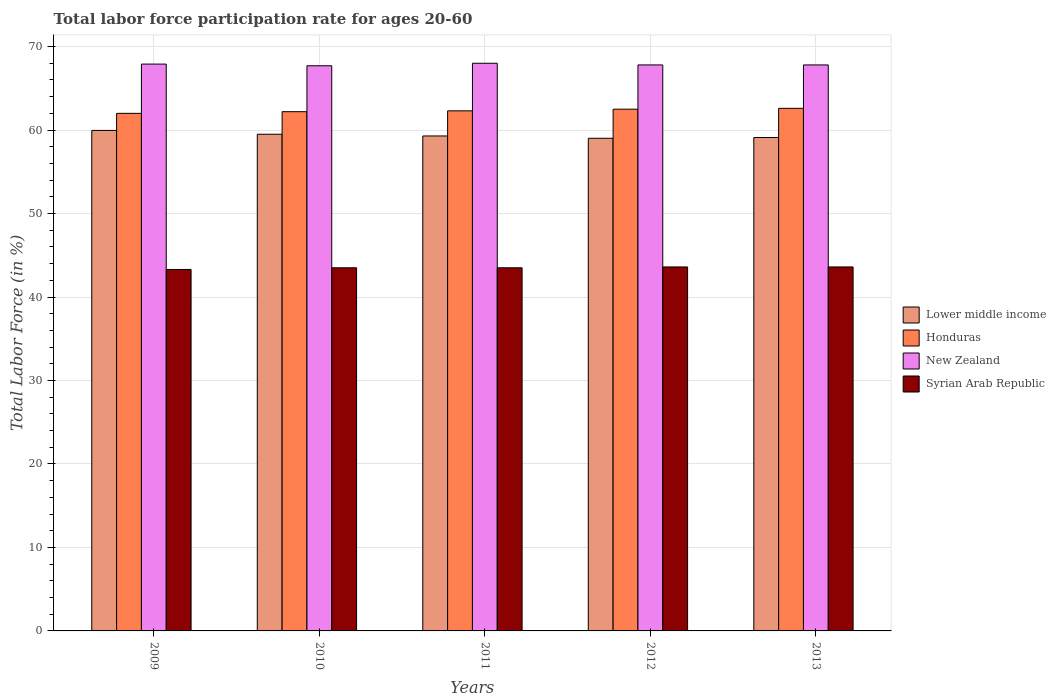How many different coloured bars are there?
Your response must be concise. 4. How many groups of bars are there?
Offer a very short reply. 5. Are the number of bars per tick equal to the number of legend labels?
Your response must be concise. Yes. Are the number of bars on each tick of the X-axis equal?
Ensure brevity in your answer.  Yes. How many bars are there on the 1st tick from the right?
Provide a short and direct response. 4. What is the label of the 5th group of bars from the left?
Ensure brevity in your answer.  2013. In how many cases, is the number of bars for a given year not equal to the number of legend labels?
Provide a short and direct response. 0. What is the labor force participation rate in New Zealand in 2009?
Offer a very short reply. 67.9. Across all years, what is the maximum labor force participation rate in Syrian Arab Republic?
Your response must be concise. 43.6. Across all years, what is the minimum labor force participation rate in Syrian Arab Republic?
Offer a terse response. 43.3. In which year was the labor force participation rate in Lower middle income minimum?
Your answer should be compact. 2012. What is the total labor force participation rate in Syrian Arab Republic in the graph?
Provide a short and direct response. 217.5. What is the difference between the labor force participation rate in New Zealand in 2010 and that in 2013?
Your answer should be very brief. -0.1. What is the difference between the labor force participation rate in New Zealand in 2009 and the labor force participation rate in Syrian Arab Republic in 2012?
Your answer should be very brief. 24.3. What is the average labor force participation rate in Lower middle income per year?
Provide a succinct answer. 59.37. In the year 2012, what is the difference between the labor force participation rate in Lower middle income and labor force participation rate in Syrian Arab Republic?
Offer a very short reply. 15.41. In how many years, is the labor force participation rate in New Zealand greater than 68 %?
Ensure brevity in your answer.  0. What is the ratio of the labor force participation rate in New Zealand in 2010 to that in 2011?
Make the answer very short. 1. Is the difference between the labor force participation rate in Lower middle income in 2009 and 2010 greater than the difference between the labor force participation rate in Syrian Arab Republic in 2009 and 2010?
Ensure brevity in your answer.  Yes. What is the difference between the highest and the second highest labor force participation rate in Honduras?
Offer a very short reply. 0.1. What is the difference between the highest and the lowest labor force participation rate in New Zealand?
Your answer should be very brief. 0.3. Is the sum of the labor force participation rate in Lower middle income in 2011 and 2013 greater than the maximum labor force participation rate in New Zealand across all years?
Make the answer very short. Yes. Is it the case that in every year, the sum of the labor force participation rate in New Zealand and labor force participation rate in Honduras is greater than the sum of labor force participation rate in Lower middle income and labor force participation rate in Syrian Arab Republic?
Offer a very short reply. Yes. What does the 4th bar from the left in 2009 represents?
Make the answer very short. Syrian Arab Republic. What does the 1st bar from the right in 2013 represents?
Provide a short and direct response. Syrian Arab Republic. How many years are there in the graph?
Your answer should be very brief. 5. What is the difference between two consecutive major ticks on the Y-axis?
Your response must be concise. 10. Are the values on the major ticks of Y-axis written in scientific E-notation?
Ensure brevity in your answer.  No. Does the graph contain grids?
Give a very brief answer. Yes. Where does the legend appear in the graph?
Offer a terse response. Center right. How many legend labels are there?
Give a very brief answer. 4. How are the legend labels stacked?
Offer a terse response. Vertical. What is the title of the graph?
Make the answer very short. Total labor force participation rate for ages 20-60. Does "Low income" appear as one of the legend labels in the graph?
Ensure brevity in your answer.  No. What is the label or title of the Y-axis?
Make the answer very short. Total Labor Force (in %). What is the Total Labor Force (in %) in Lower middle income in 2009?
Your answer should be very brief. 59.95. What is the Total Labor Force (in %) of Honduras in 2009?
Keep it short and to the point. 62. What is the Total Labor Force (in %) in New Zealand in 2009?
Keep it short and to the point. 67.9. What is the Total Labor Force (in %) of Syrian Arab Republic in 2009?
Offer a very short reply. 43.3. What is the Total Labor Force (in %) in Lower middle income in 2010?
Ensure brevity in your answer.  59.5. What is the Total Labor Force (in %) of Honduras in 2010?
Your response must be concise. 62.2. What is the Total Labor Force (in %) in New Zealand in 2010?
Offer a very short reply. 67.7. What is the Total Labor Force (in %) in Syrian Arab Republic in 2010?
Offer a terse response. 43.5. What is the Total Labor Force (in %) of Lower middle income in 2011?
Ensure brevity in your answer.  59.29. What is the Total Labor Force (in %) of Honduras in 2011?
Offer a very short reply. 62.3. What is the Total Labor Force (in %) in Syrian Arab Republic in 2011?
Your response must be concise. 43.5. What is the Total Labor Force (in %) in Lower middle income in 2012?
Offer a terse response. 59.01. What is the Total Labor Force (in %) of Honduras in 2012?
Your response must be concise. 62.5. What is the Total Labor Force (in %) in New Zealand in 2012?
Your answer should be very brief. 67.8. What is the Total Labor Force (in %) in Syrian Arab Republic in 2012?
Offer a very short reply. 43.6. What is the Total Labor Force (in %) of Lower middle income in 2013?
Your answer should be very brief. 59.11. What is the Total Labor Force (in %) of Honduras in 2013?
Provide a succinct answer. 62.6. What is the Total Labor Force (in %) of New Zealand in 2013?
Your answer should be very brief. 67.8. What is the Total Labor Force (in %) in Syrian Arab Republic in 2013?
Offer a terse response. 43.6. Across all years, what is the maximum Total Labor Force (in %) in Lower middle income?
Your answer should be very brief. 59.95. Across all years, what is the maximum Total Labor Force (in %) in Honduras?
Your answer should be compact. 62.6. Across all years, what is the maximum Total Labor Force (in %) in New Zealand?
Offer a very short reply. 68. Across all years, what is the maximum Total Labor Force (in %) of Syrian Arab Republic?
Your answer should be compact. 43.6. Across all years, what is the minimum Total Labor Force (in %) of Lower middle income?
Make the answer very short. 59.01. Across all years, what is the minimum Total Labor Force (in %) of New Zealand?
Make the answer very short. 67.7. Across all years, what is the minimum Total Labor Force (in %) of Syrian Arab Republic?
Make the answer very short. 43.3. What is the total Total Labor Force (in %) of Lower middle income in the graph?
Keep it short and to the point. 296.86. What is the total Total Labor Force (in %) in Honduras in the graph?
Give a very brief answer. 311.6. What is the total Total Labor Force (in %) in New Zealand in the graph?
Offer a very short reply. 339.2. What is the total Total Labor Force (in %) in Syrian Arab Republic in the graph?
Make the answer very short. 217.5. What is the difference between the Total Labor Force (in %) of Lower middle income in 2009 and that in 2010?
Your answer should be compact. 0.46. What is the difference between the Total Labor Force (in %) in Honduras in 2009 and that in 2010?
Provide a succinct answer. -0.2. What is the difference between the Total Labor Force (in %) of Syrian Arab Republic in 2009 and that in 2010?
Your answer should be very brief. -0.2. What is the difference between the Total Labor Force (in %) of Lower middle income in 2009 and that in 2011?
Your response must be concise. 0.66. What is the difference between the Total Labor Force (in %) of Lower middle income in 2009 and that in 2012?
Your response must be concise. 0.94. What is the difference between the Total Labor Force (in %) of Honduras in 2009 and that in 2012?
Your response must be concise. -0.5. What is the difference between the Total Labor Force (in %) of Syrian Arab Republic in 2009 and that in 2012?
Provide a succinct answer. -0.3. What is the difference between the Total Labor Force (in %) of Lower middle income in 2009 and that in 2013?
Give a very brief answer. 0.85. What is the difference between the Total Labor Force (in %) of Honduras in 2009 and that in 2013?
Ensure brevity in your answer.  -0.6. What is the difference between the Total Labor Force (in %) of New Zealand in 2009 and that in 2013?
Your response must be concise. 0.1. What is the difference between the Total Labor Force (in %) of Syrian Arab Republic in 2009 and that in 2013?
Offer a very short reply. -0.3. What is the difference between the Total Labor Force (in %) in Lower middle income in 2010 and that in 2011?
Make the answer very short. 0.21. What is the difference between the Total Labor Force (in %) in New Zealand in 2010 and that in 2011?
Ensure brevity in your answer.  -0.3. What is the difference between the Total Labor Force (in %) of Syrian Arab Republic in 2010 and that in 2011?
Your response must be concise. 0. What is the difference between the Total Labor Force (in %) in Lower middle income in 2010 and that in 2012?
Your answer should be very brief. 0.48. What is the difference between the Total Labor Force (in %) in Syrian Arab Republic in 2010 and that in 2012?
Keep it short and to the point. -0.1. What is the difference between the Total Labor Force (in %) in Lower middle income in 2010 and that in 2013?
Offer a very short reply. 0.39. What is the difference between the Total Labor Force (in %) of New Zealand in 2010 and that in 2013?
Make the answer very short. -0.1. What is the difference between the Total Labor Force (in %) of Lower middle income in 2011 and that in 2012?
Give a very brief answer. 0.28. What is the difference between the Total Labor Force (in %) of New Zealand in 2011 and that in 2012?
Make the answer very short. 0.2. What is the difference between the Total Labor Force (in %) of Lower middle income in 2011 and that in 2013?
Offer a terse response. 0.19. What is the difference between the Total Labor Force (in %) of Syrian Arab Republic in 2011 and that in 2013?
Offer a terse response. -0.1. What is the difference between the Total Labor Force (in %) in Lower middle income in 2012 and that in 2013?
Your answer should be compact. -0.09. What is the difference between the Total Labor Force (in %) of Honduras in 2012 and that in 2013?
Ensure brevity in your answer.  -0.1. What is the difference between the Total Labor Force (in %) in Syrian Arab Republic in 2012 and that in 2013?
Ensure brevity in your answer.  0. What is the difference between the Total Labor Force (in %) of Lower middle income in 2009 and the Total Labor Force (in %) of Honduras in 2010?
Make the answer very short. -2.25. What is the difference between the Total Labor Force (in %) of Lower middle income in 2009 and the Total Labor Force (in %) of New Zealand in 2010?
Your answer should be very brief. -7.75. What is the difference between the Total Labor Force (in %) in Lower middle income in 2009 and the Total Labor Force (in %) in Syrian Arab Republic in 2010?
Your answer should be compact. 16.45. What is the difference between the Total Labor Force (in %) in Honduras in 2009 and the Total Labor Force (in %) in New Zealand in 2010?
Your response must be concise. -5.7. What is the difference between the Total Labor Force (in %) of Honduras in 2009 and the Total Labor Force (in %) of Syrian Arab Republic in 2010?
Provide a succinct answer. 18.5. What is the difference between the Total Labor Force (in %) of New Zealand in 2009 and the Total Labor Force (in %) of Syrian Arab Republic in 2010?
Make the answer very short. 24.4. What is the difference between the Total Labor Force (in %) in Lower middle income in 2009 and the Total Labor Force (in %) in Honduras in 2011?
Ensure brevity in your answer.  -2.35. What is the difference between the Total Labor Force (in %) of Lower middle income in 2009 and the Total Labor Force (in %) of New Zealand in 2011?
Your answer should be compact. -8.05. What is the difference between the Total Labor Force (in %) in Lower middle income in 2009 and the Total Labor Force (in %) in Syrian Arab Republic in 2011?
Make the answer very short. 16.45. What is the difference between the Total Labor Force (in %) of New Zealand in 2009 and the Total Labor Force (in %) of Syrian Arab Republic in 2011?
Provide a succinct answer. 24.4. What is the difference between the Total Labor Force (in %) of Lower middle income in 2009 and the Total Labor Force (in %) of Honduras in 2012?
Your answer should be very brief. -2.55. What is the difference between the Total Labor Force (in %) in Lower middle income in 2009 and the Total Labor Force (in %) in New Zealand in 2012?
Give a very brief answer. -7.85. What is the difference between the Total Labor Force (in %) in Lower middle income in 2009 and the Total Labor Force (in %) in Syrian Arab Republic in 2012?
Offer a very short reply. 16.35. What is the difference between the Total Labor Force (in %) of Honduras in 2009 and the Total Labor Force (in %) of Syrian Arab Republic in 2012?
Ensure brevity in your answer.  18.4. What is the difference between the Total Labor Force (in %) in New Zealand in 2009 and the Total Labor Force (in %) in Syrian Arab Republic in 2012?
Give a very brief answer. 24.3. What is the difference between the Total Labor Force (in %) in Lower middle income in 2009 and the Total Labor Force (in %) in Honduras in 2013?
Provide a succinct answer. -2.65. What is the difference between the Total Labor Force (in %) of Lower middle income in 2009 and the Total Labor Force (in %) of New Zealand in 2013?
Your response must be concise. -7.85. What is the difference between the Total Labor Force (in %) in Lower middle income in 2009 and the Total Labor Force (in %) in Syrian Arab Republic in 2013?
Give a very brief answer. 16.35. What is the difference between the Total Labor Force (in %) of Honduras in 2009 and the Total Labor Force (in %) of New Zealand in 2013?
Give a very brief answer. -5.8. What is the difference between the Total Labor Force (in %) of Honduras in 2009 and the Total Labor Force (in %) of Syrian Arab Republic in 2013?
Provide a short and direct response. 18.4. What is the difference between the Total Labor Force (in %) in New Zealand in 2009 and the Total Labor Force (in %) in Syrian Arab Republic in 2013?
Your response must be concise. 24.3. What is the difference between the Total Labor Force (in %) in Lower middle income in 2010 and the Total Labor Force (in %) in Honduras in 2011?
Provide a succinct answer. -2.8. What is the difference between the Total Labor Force (in %) of Lower middle income in 2010 and the Total Labor Force (in %) of New Zealand in 2011?
Your response must be concise. -8.5. What is the difference between the Total Labor Force (in %) of Lower middle income in 2010 and the Total Labor Force (in %) of Syrian Arab Republic in 2011?
Offer a terse response. 16. What is the difference between the Total Labor Force (in %) of Honduras in 2010 and the Total Labor Force (in %) of New Zealand in 2011?
Ensure brevity in your answer.  -5.8. What is the difference between the Total Labor Force (in %) in New Zealand in 2010 and the Total Labor Force (in %) in Syrian Arab Republic in 2011?
Make the answer very short. 24.2. What is the difference between the Total Labor Force (in %) in Lower middle income in 2010 and the Total Labor Force (in %) in Honduras in 2012?
Offer a terse response. -3. What is the difference between the Total Labor Force (in %) in Lower middle income in 2010 and the Total Labor Force (in %) in New Zealand in 2012?
Provide a short and direct response. -8.3. What is the difference between the Total Labor Force (in %) of Lower middle income in 2010 and the Total Labor Force (in %) of Syrian Arab Republic in 2012?
Your response must be concise. 15.9. What is the difference between the Total Labor Force (in %) of Honduras in 2010 and the Total Labor Force (in %) of New Zealand in 2012?
Ensure brevity in your answer.  -5.6. What is the difference between the Total Labor Force (in %) in Honduras in 2010 and the Total Labor Force (in %) in Syrian Arab Republic in 2012?
Your answer should be compact. 18.6. What is the difference between the Total Labor Force (in %) in New Zealand in 2010 and the Total Labor Force (in %) in Syrian Arab Republic in 2012?
Keep it short and to the point. 24.1. What is the difference between the Total Labor Force (in %) of Lower middle income in 2010 and the Total Labor Force (in %) of Honduras in 2013?
Offer a very short reply. -3.1. What is the difference between the Total Labor Force (in %) in Lower middle income in 2010 and the Total Labor Force (in %) in New Zealand in 2013?
Make the answer very short. -8.3. What is the difference between the Total Labor Force (in %) of Lower middle income in 2010 and the Total Labor Force (in %) of Syrian Arab Republic in 2013?
Your answer should be very brief. 15.9. What is the difference between the Total Labor Force (in %) in Honduras in 2010 and the Total Labor Force (in %) in Syrian Arab Republic in 2013?
Provide a succinct answer. 18.6. What is the difference between the Total Labor Force (in %) in New Zealand in 2010 and the Total Labor Force (in %) in Syrian Arab Republic in 2013?
Provide a short and direct response. 24.1. What is the difference between the Total Labor Force (in %) in Lower middle income in 2011 and the Total Labor Force (in %) in Honduras in 2012?
Offer a very short reply. -3.21. What is the difference between the Total Labor Force (in %) of Lower middle income in 2011 and the Total Labor Force (in %) of New Zealand in 2012?
Ensure brevity in your answer.  -8.51. What is the difference between the Total Labor Force (in %) of Lower middle income in 2011 and the Total Labor Force (in %) of Syrian Arab Republic in 2012?
Provide a succinct answer. 15.69. What is the difference between the Total Labor Force (in %) in New Zealand in 2011 and the Total Labor Force (in %) in Syrian Arab Republic in 2012?
Give a very brief answer. 24.4. What is the difference between the Total Labor Force (in %) in Lower middle income in 2011 and the Total Labor Force (in %) in Honduras in 2013?
Give a very brief answer. -3.31. What is the difference between the Total Labor Force (in %) in Lower middle income in 2011 and the Total Labor Force (in %) in New Zealand in 2013?
Your answer should be compact. -8.51. What is the difference between the Total Labor Force (in %) in Lower middle income in 2011 and the Total Labor Force (in %) in Syrian Arab Republic in 2013?
Keep it short and to the point. 15.69. What is the difference between the Total Labor Force (in %) of New Zealand in 2011 and the Total Labor Force (in %) of Syrian Arab Republic in 2013?
Keep it short and to the point. 24.4. What is the difference between the Total Labor Force (in %) of Lower middle income in 2012 and the Total Labor Force (in %) of Honduras in 2013?
Offer a terse response. -3.59. What is the difference between the Total Labor Force (in %) of Lower middle income in 2012 and the Total Labor Force (in %) of New Zealand in 2013?
Keep it short and to the point. -8.79. What is the difference between the Total Labor Force (in %) of Lower middle income in 2012 and the Total Labor Force (in %) of Syrian Arab Republic in 2013?
Offer a very short reply. 15.41. What is the difference between the Total Labor Force (in %) in New Zealand in 2012 and the Total Labor Force (in %) in Syrian Arab Republic in 2013?
Give a very brief answer. 24.2. What is the average Total Labor Force (in %) in Lower middle income per year?
Provide a succinct answer. 59.37. What is the average Total Labor Force (in %) of Honduras per year?
Keep it short and to the point. 62.32. What is the average Total Labor Force (in %) of New Zealand per year?
Offer a very short reply. 67.84. What is the average Total Labor Force (in %) of Syrian Arab Republic per year?
Your answer should be compact. 43.5. In the year 2009, what is the difference between the Total Labor Force (in %) of Lower middle income and Total Labor Force (in %) of Honduras?
Provide a succinct answer. -2.05. In the year 2009, what is the difference between the Total Labor Force (in %) in Lower middle income and Total Labor Force (in %) in New Zealand?
Offer a terse response. -7.95. In the year 2009, what is the difference between the Total Labor Force (in %) of Lower middle income and Total Labor Force (in %) of Syrian Arab Republic?
Provide a succinct answer. 16.65. In the year 2009, what is the difference between the Total Labor Force (in %) of Honduras and Total Labor Force (in %) of New Zealand?
Your response must be concise. -5.9. In the year 2009, what is the difference between the Total Labor Force (in %) in Honduras and Total Labor Force (in %) in Syrian Arab Republic?
Make the answer very short. 18.7. In the year 2009, what is the difference between the Total Labor Force (in %) in New Zealand and Total Labor Force (in %) in Syrian Arab Republic?
Make the answer very short. 24.6. In the year 2010, what is the difference between the Total Labor Force (in %) of Lower middle income and Total Labor Force (in %) of Honduras?
Give a very brief answer. -2.7. In the year 2010, what is the difference between the Total Labor Force (in %) in Lower middle income and Total Labor Force (in %) in New Zealand?
Ensure brevity in your answer.  -8.2. In the year 2010, what is the difference between the Total Labor Force (in %) of Lower middle income and Total Labor Force (in %) of Syrian Arab Republic?
Ensure brevity in your answer.  16. In the year 2010, what is the difference between the Total Labor Force (in %) in Honduras and Total Labor Force (in %) in New Zealand?
Keep it short and to the point. -5.5. In the year 2010, what is the difference between the Total Labor Force (in %) in New Zealand and Total Labor Force (in %) in Syrian Arab Republic?
Give a very brief answer. 24.2. In the year 2011, what is the difference between the Total Labor Force (in %) in Lower middle income and Total Labor Force (in %) in Honduras?
Keep it short and to the point. -3.01. In the year 2011, what is the difference between the Total Labor Force (in %) in Lower middle income and Total Labor Force (in %) in New Zealand?
Offer a very short reply. -8.71. In the year 2011, what is the difference between the Total Labor Force (in %) of Lower middle income and Total Labor Force (in %) of Syrian Arab Republic?
Your response must be concise. 15.79. In the year 2011, what is the difference between the Total Labor Force (in %) in Honduras and Total Labor Force (in %) in Syrian Arab Republic?
Provide a succinct answer. 18.8. In the year 2012, what is the difference between the Total Labor Force (in %) of Lower middle income and Total Labor Force (in %) of Honduras?
Provide a succinct answer. -3.49. In the year 2012, what is the difference between the Total Labor Force (in %) in Lower middle income and Total Labor Force (in %) in New Zealand?
Give a very brief answer. -8.79. In the year 2012, what is the difference between the Total Labor Force (in %) in Lower middle income and Total Labor Force (in %) in Syrian Arab Republic?
Provide a succinct answer. 15.41. In the year 2012, what is the difference between the Total Labor Force (in %) of Honduras and Total Labor Force (in %) of New Zealand?
Your response must be concise. -5.3. In the year 2012, what is the difference between the Total Labor Force (in %) in New Zealand and Total Labor Force (in %) in Syrian Arab Republic?
Offer a very short reply. 24.2. In the year 2013, what is the difference between the Total Labor Force (in %) of Lower middle income and Total Labor Force (in %) of Honduras?
Provide a short and direct response. -3.49. In the year 2013, what is the difference between the Total Labor Force (in %) of Lower middle income and Total Labor Force (in %) of New Zealand?
Ensure brevity in your answer.  -8.69. In the year 2013, what is the difference between the Total Labor Force (in %) in Lower middle income and Total Labor Force (in %) in Syrian Arab Republic?
Provide a succinct answer. 15.51. In the year 2013, what is the difference between the Total Labor Force (in %) in Honduras and Total Labor Force (in %) in New Zealand?
Keep it short and to the point. -5.2. In the year 2013, what is the difference between the Total Labor Force (in %) in Honduras and Total Labor Force (in %) in Syrian Arab Republic?
Offer a terse response. 19. In the year 2013, what is the difference between the Total Labor Force (in %) of New Zealand and Total Labor Force (in %) of Syrian Arab Republic?
Your response must be concise. 24.2. What is the ratio of the Total Labor Force (in %) in Lower middle income in 2009 to that in 2010?
Make the answer very short. 1.01. What is the ratio of the Total Labor Force (in %) in New Zealand in 2009 to that in 2010?
Offer a terse response. 1. What is the ratio of the Total Labor Force (in %) in Syrian Arab Republic in 2009 to that in 2010?
Your response must be concise. 1. What is the ratio of the Total Labor Force (in %) in Lower middle income in 2009 to that in 2011?
Provide a short and direct response. 1.01. What is the ratio of the Total Labor Force (in %) of New Zealand in 2009 to that in 2011?
Offer a terse response. 1. What is the ratio of the Total Labor Force (in %) of Syrian Arab Republic in 2009 to that in 2011?
Provide a succinct answer. 1. What is the ratio of the Total Labor Force (in %) in Lower middle income in 2009 to that in 2012?
Give a very brief answer. 1.02. What is the ratio of the Total Labor Force (in %) of Honduras in 2009 to that in 2012?
Offer a very short reply. 0.99. What is the ratio of the Total Labor Force (in %) of New Zealand in 2009 to that in 2012?
Provide a short and direct response. 1. What is the ratio of the Total Labor Force (in %) of Syrian Arab Republic in 2009 to that in 2012?
Offer a terse response. 0.99. What is the ratio of the Total Labor Force (in %) of Lower middle income in 2009 to that in 2013?
Your answer should be very brief. 1.01. What is the ratio of the Total Labor Force (in %) of Syrian Arab Republic in 2009 to that in 2013?
Your answer should be very brief. 0.99. What is the ratio of the Total Labor Force (in %) of Lower middle income in 2010 to that in 2011?
Your answer should be very brief. 1. What is the ratio of the Total Labor Force (in %) of New Zealand in 2010 to that in 2011?
Your answer should be compact. 1. What is the ratio of the Total Labor Force (in %) in Lower middle income in 2010 to that in 2012?
Give a very brief answer. 1.01. What is the ratio of the Total Labor Force (in %) of New Zealand in 2010 to that in 2012?
Ensure brevity in your answer.  1. What is the ratio of the Total Labor Force (in %) in Syrian Arab Republic in 2010 to that in 2012?
Your answer should be very brief. 1. What is the ratio of the Total Labor Force (in %) in Lower middle income in 2010 to that in 2013?
Offer a very short reply. 1.01. What is the ratio of the Total Labor Force (in %) of Syrian Arab Republic in 2010 to that in 2013?
Provide a short and direct response. 1. What is the ratio of the Total Labor Force (in %) of Syrian Arab Republic in 2011 to that in 2012?
Make the answer very short. 1. What is the ratio of the Total Labor Force (in %) in Syrian Arab Republic in 2011 to that in 2013?
Offer a very short reply. 1. What is the ratio of the Total Labor Force (in %) in Syrian Arab Republic in 2012 to that in 2013?
Your response must be concise. 1. What is the difference between the highest and the second highest Total Labor Force (in %) in Lower middle income?
Your response must be concise. 0.46. What is the difference between the highest and the second highest Total Labor Force (in %) in Honduras?
Your answer should be very brief. 0.1. What is the difference between the highest and the second highest Total Labor Force (in %) of Syrian Arab Republic?
Offer a very short reply. 0. What is the difference between the highest and the lowest Total Labor Force (in %) in Lower middle income?
Provide a short and direct response. 0.94. 